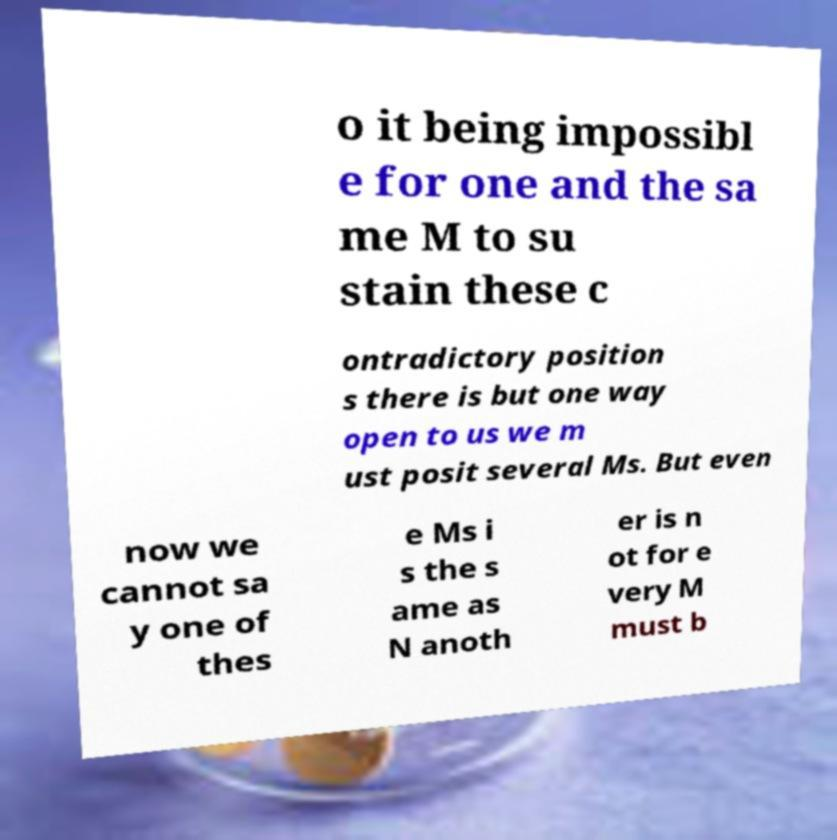Could you extract and type out the text from this image? o it being impossibl e for one and the sa me M to su stain these c ontradictory position s there is but one way open to us we m ust posit several Ms. But even now we cannot sa y one of thes e Ms i s the s ame as N anoth er is n ot for e very M must b 